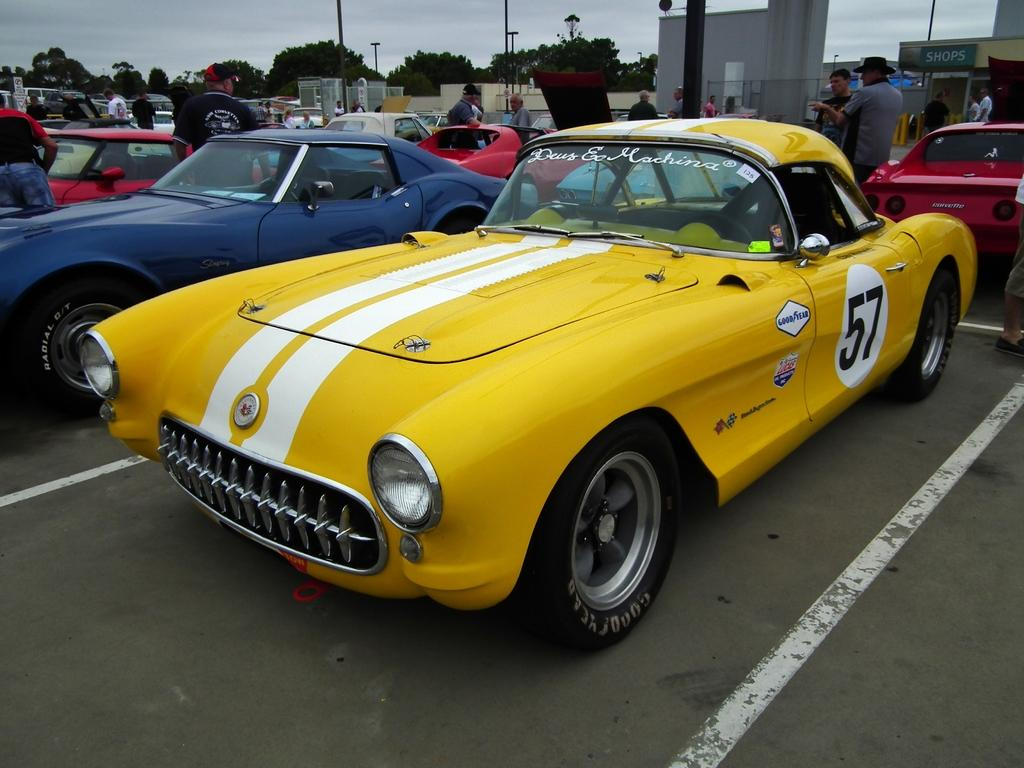What type of vehicles can be seen in the image? There are cars in the image. What are the people on the road doing? There are people standing on the road in the image. What structures can be seen in the image? There are poles, trees, a board, walls, and other objects in the image. What is visible in the background of the image? The sky is visible in the background of the image. How many eyes can be seen on the tree in the image? There are no eyes present on the tree in the image, as trees do not have eyes. What rhythm is being played by the cars in the image? There is no rhythm being played by the cars in the image; they are stationary vehicles. 